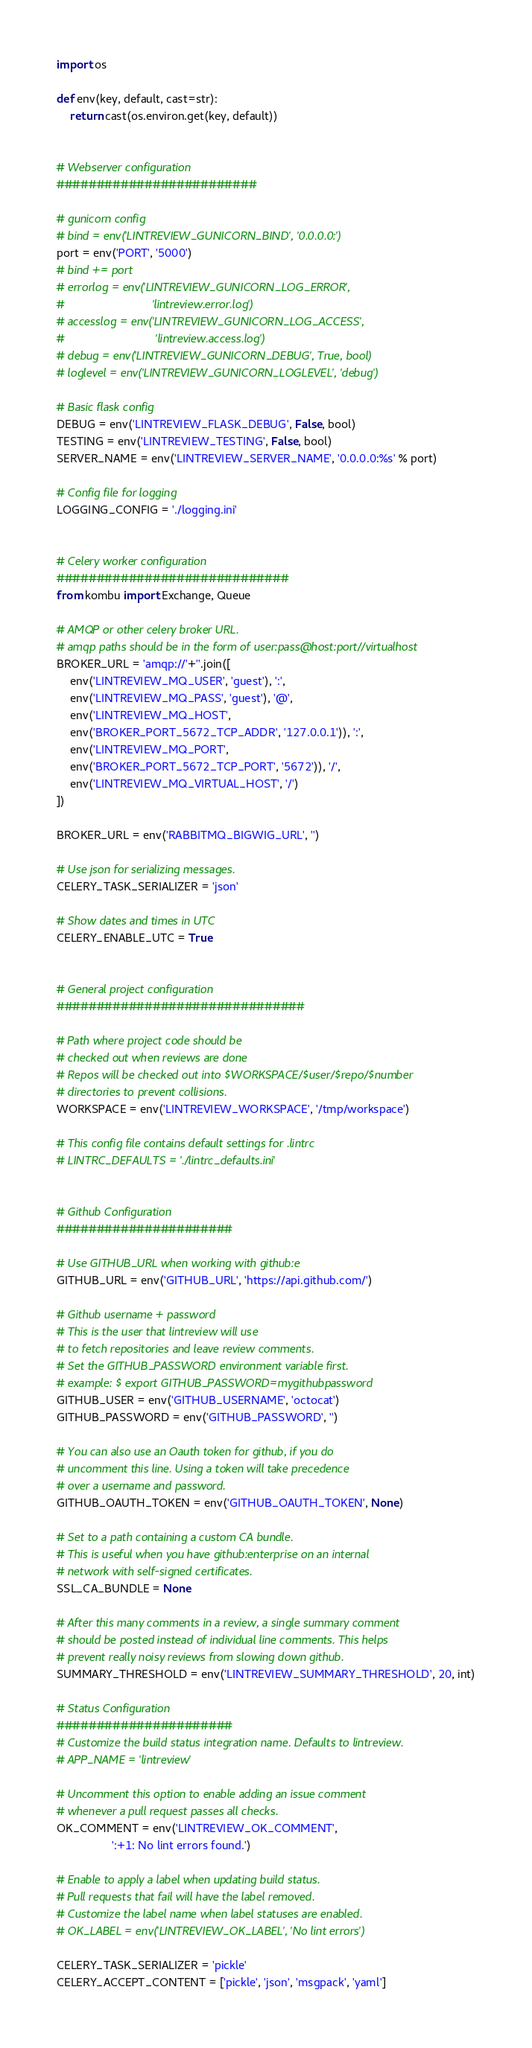Convert code to text. <code><loc_0><loc_0><loc_500><loc_500><_Python_>import os

def env(key, default, cast=str):
    return cast(os.environ.get(key, default))


# Webserver configuration
#########################

# gunicorn config
# bind = env('LINTREVIEW_GUNICORN_BIND', '0.0.0.0:')
port = env('PORT', '5000')
# bind += port
# errorlog = env('LINTREVIEW_GUNICORN_LOG_ERROR',
#                           'lintreview.error.log')
# accesslog = env('LINTREVIEW_GUNICORN_LOG_ACCESS',
#                            'lintreview.access.log')
# debug = env('LINTREVIEW_GUNICORN_DEBUG', True, bool)
# loglevel = env('LINTREVIEW_GUNICORN_LOGLEVEL', 'debug')

# Basic flask config
DEBUG = env('LINTREVIEW_FLASK_DEBUG', False, bool)
TESTING = env('LINTREVIEW_TESTING', False, bool)
SERVER_NAME = env('LINTREVIEW_SERVER_NAME', '0.0.0.0:%s' % port)

# Config file for logging
LOGGING_CONFIG = './logging.ini'


# Celery worker configuration
#############################
from kombu import Exchange, Queue

# AMQP or other celery broker URL.
# amqp paths should be in the form of user:pass@host:port//virtualhost
BROKER_URL = 'amqp://'+''.join([
    env('LINTREVIEW_MQ_USER', 'guest'), ':',
    env('LINTREVIEW_MQ_PASS', 'guest'), '@',
    env('LINTREVIEW_MQ_HOST',
    env('BROKER_PORT_5672_TCP_ADDR', '127.0.0.1')), ':',
    env('LINTREVIEW_MQ_PORT',
    env('BROKER_PORT_5672_TCP_PORT', '5672')), '/',
    env('LINTREVIEW_MQ_VIRTUAL_HOST', '/')
])

BROKER_URL = env('RABBITMQ_BIGWIG_URL', '')

# Use json for serializing messages.
CELERY_TASK_SERIALIZER = 'json'

# Show dates and times in UTC
CELERY_ENABLE_UTC = True


# General project configuration
###############################

# Path where project code should be
# checked out when reviews are done
# Repos will be checked out into $WORKSPACE/$user/$repo/$number
# directories to prevent collisions.
WORKSPACE = env('LINTREVIEW_WORKSPACE', '/tmp/workspace')

# This config file contains default settings for .lintrc
# LINTRC_DEFAULTS = './lintrc_defaults.ini'


# Github Configuration
######################

# Use GITHUB_URL when working with github:e
GITHUB_URL = env('GITHUB_URL', 'https://api.github.com/')

# Github username + password
# This is the user that lintreview will use
# to fetch repositories and leave review comments.
# Set the GITHUB_PASSWORD environment variable first.
# example: $ export GITHUB_PASSWORD=mygithubpassword
GITHUB_USER = env('GITHUB_USERNAME', 'octocat')
GITHUB_PASSWORD = env('GITHUB_PASSWORD', '')

# You can also use an Oauth token for github, if you do
# uncomment this line. Using a token will take precedence
# over a username and password.
GITHUB_OAUTH_TOKEN = env('GITHUB_OAUTH_TOKEN', None)

# Set to a path containing a custom CA bundle.
# This is useful when you have github:enterprise on an internal
# network with self-signed certificates.
SSL_CA_BUNDLE = None

# After this many comments in a review, a single summary comment
# should be posted instead of individual line comments. This helps
# prevent really noisy reviews from slowing down github.
SUMMARY_THRESHOLD = env('LINTREVIEW_SUMMARY_THRESHOLD', 20, int)

# Status Configuration
######################
# Customize the build status integration name. Defaults to lintreview.
# APP_NAME = 'lintreview'

# Uncomment this option to enable adding an issue comment
# whenever a pull request passes all checks.
OK_COMMENT = env('LINTREVIEW_OK_COMMENT',
                 ':+1: No lint errors found.')

# Enable to apply a label when updating build status.
# Pull requests that fail will have the label removed.
# Customize the label name when label statuses are enabled.
# OK_LABEL = env('LINTREVIEW_OK_LABEL', 'No lint errors')

CELERY_TASK_SERIALIZER = 'pickle'
CELERY_ACCEPT_CONTENT = ['pickle', 'json', 'msgpack', 'yaml']
</code> 